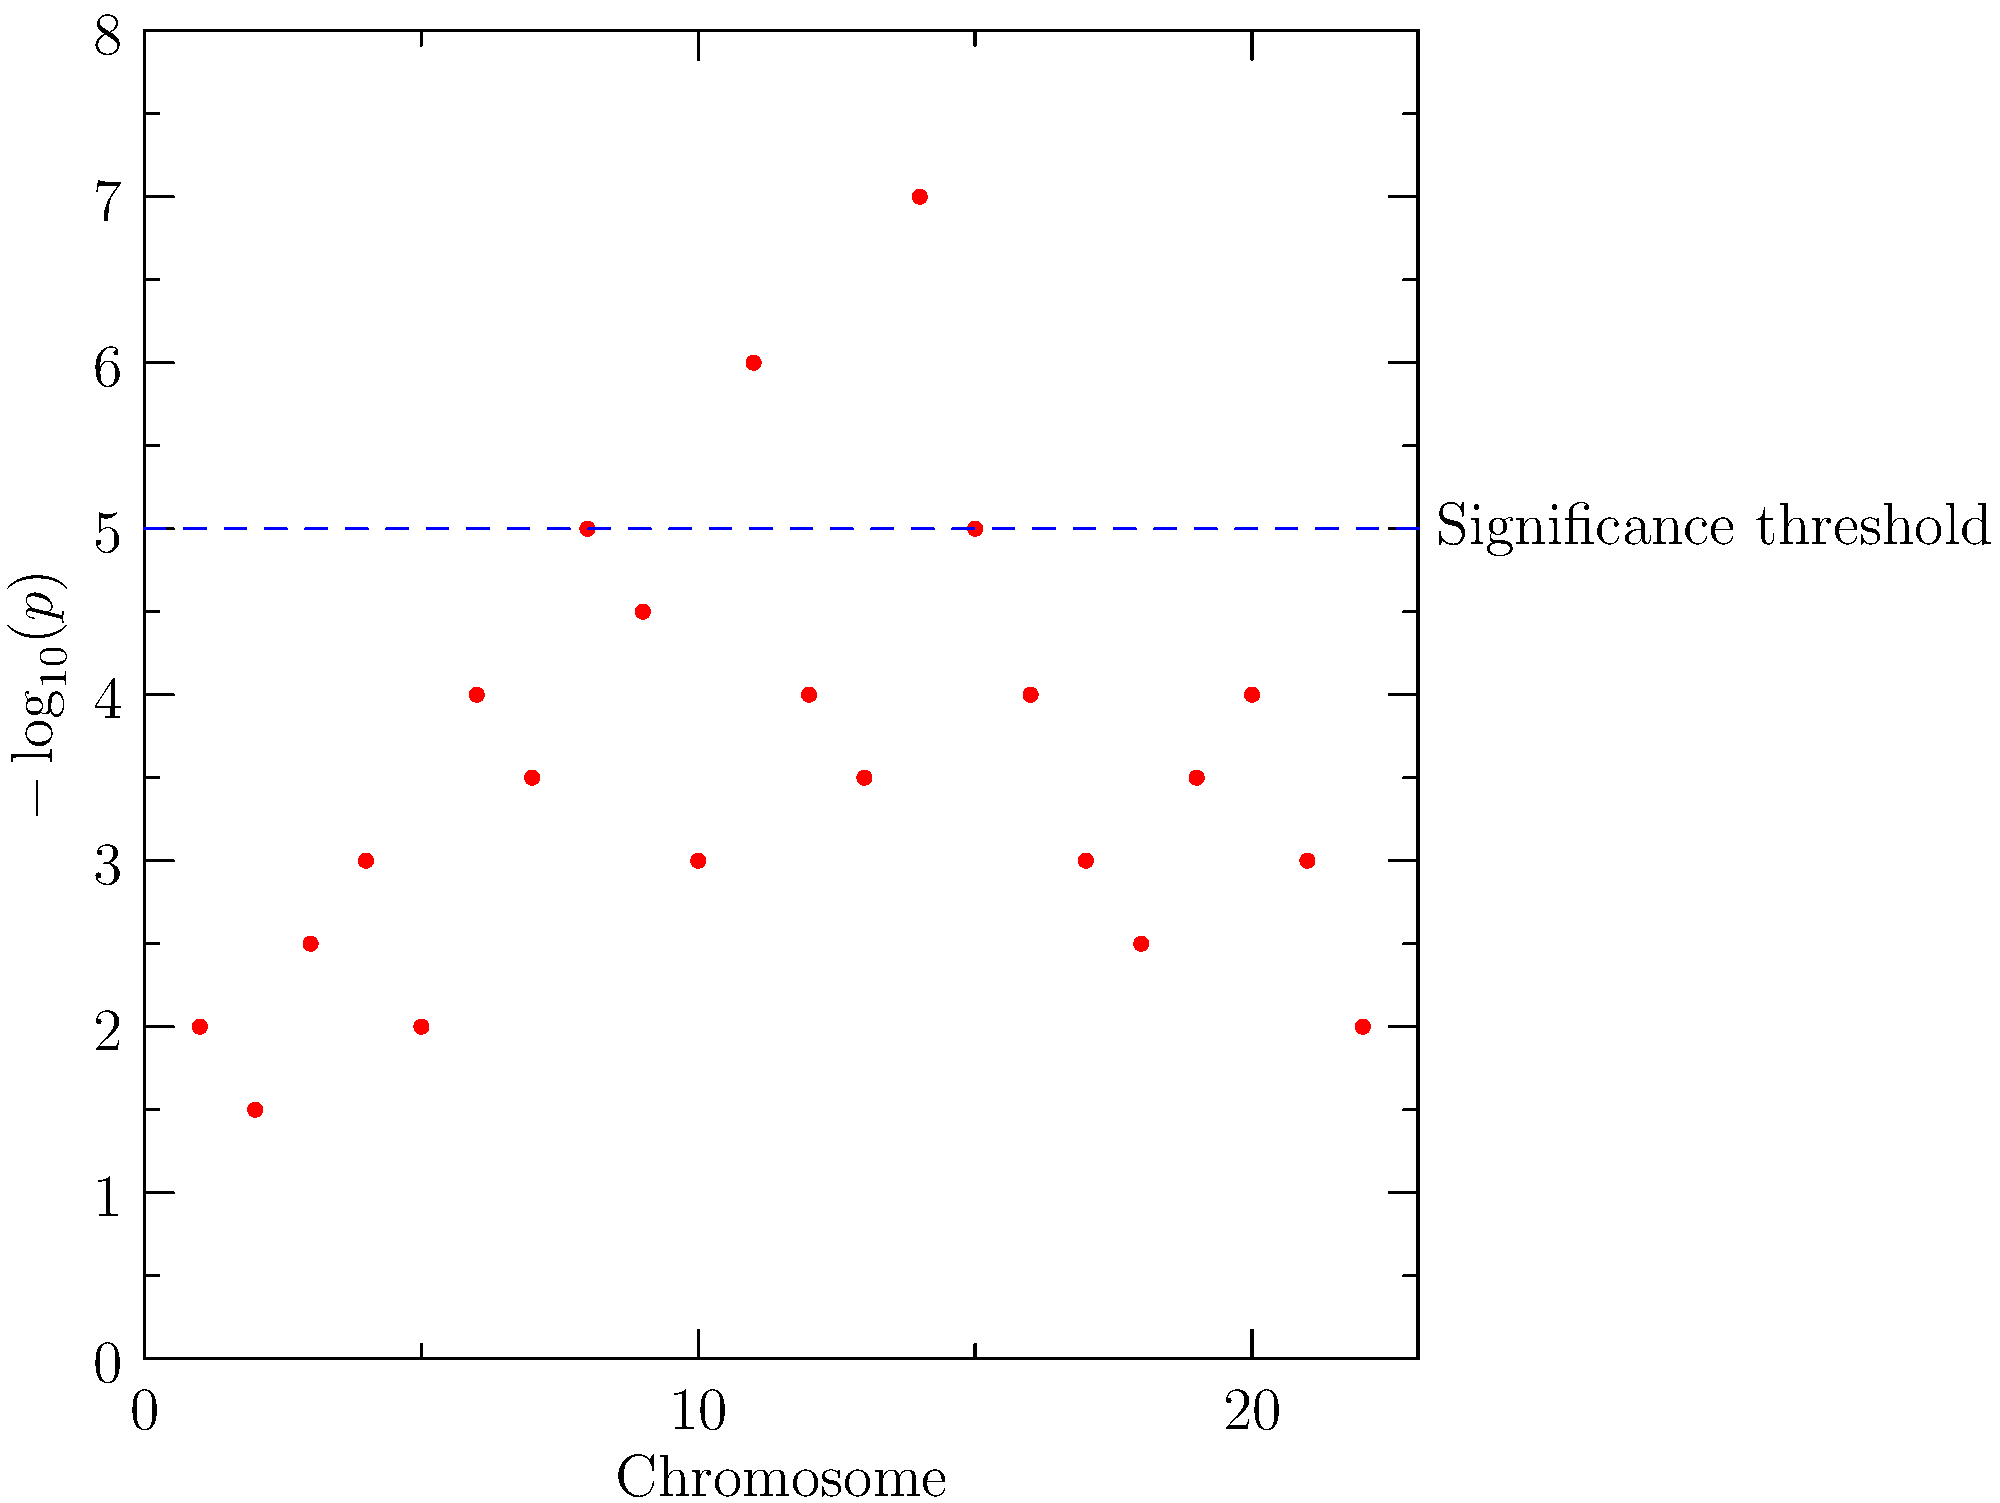Based on the Manhattan plot from a genome-wide association study (GWAS) shown above, which chromosomes contain genetic variants that are significantly associated with the trait of interest? Assume a significance threshold of $-\log_{10}(p) > 5$. To interpret this Manhattan plot and identify significant genetic variants, we need to follow these steps:

1. Understand the plot:
   - The x-axis represents chromosomes (1-22).
   - The y-axis represents $-\log_{10}(p)$, where $p$ is the p-value for each genetic variant.
   - Each dot represents a genetic variant.

2. Identify the significance threshold:
   - The question states that the significance threshold is $-\log_{10}(p) > 5$.
   - This is represented by the blue dashed line on the plot.

3. Examine each chromosome:
   - Look for dots (genetic variants) that exceed the significance threshold line.
   - Chromosome 14 has a dot clearly above the threshold line.
   - Chromosome 11 has a dot that appears to be just touching or slightly above the threshold line.

4. Determine significant chromosomes:
   - Chromosome 14 definitely contains a significant genetic variant.
   - Chromosome 11 may contain a significant genetic variant, but it's very close to the threshold.

5. Conclusion:
   - We can confidently say that chromosome 14 contains a significant genetic variant.
   - Chromosome 11 is borderline and might be included depending on the exact value and how conservative we want to be in our analysis.
Answer: Chromosome 14 (and possibly chromosome 11) 